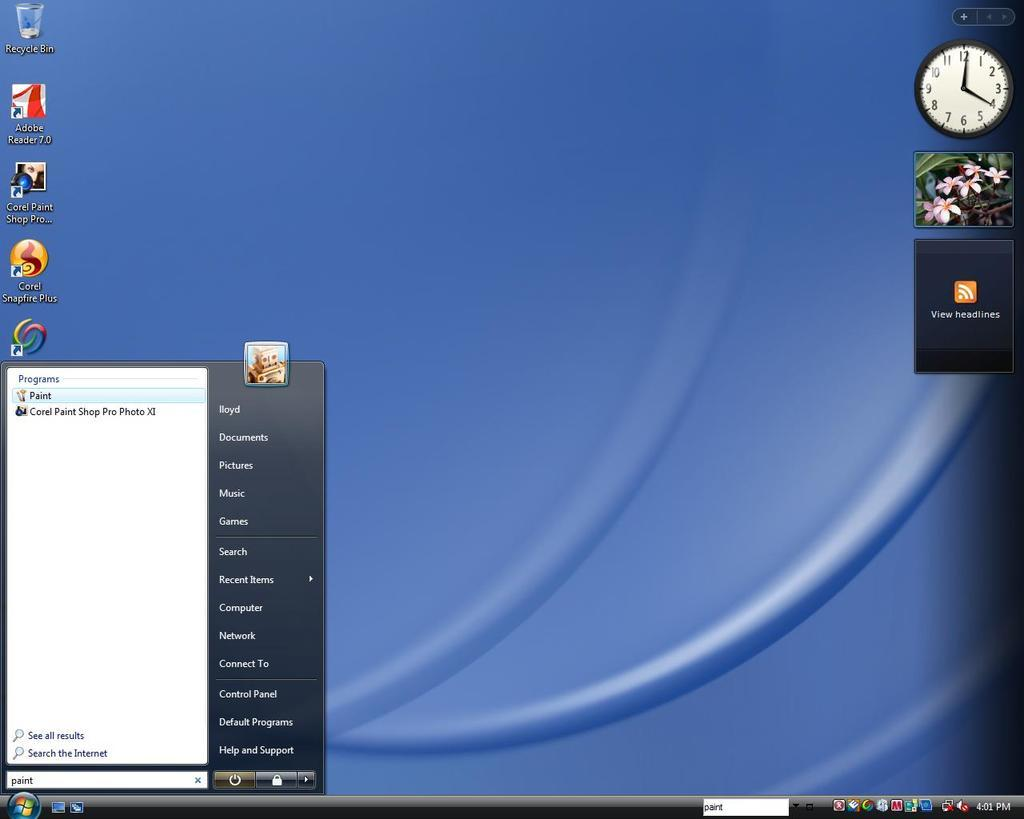<image>
Offer a succinct explanation of the picture presented. A computer screen that shows the Recycle Bin in the upper left corner. 